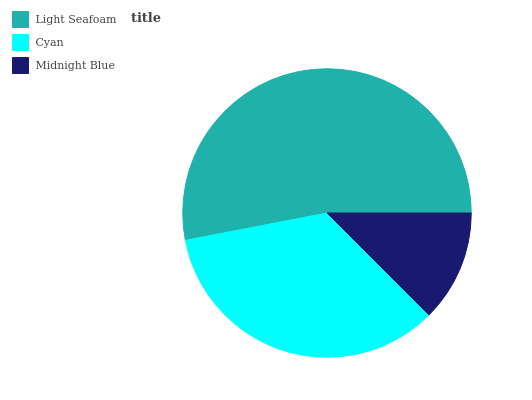Is Midnight Blue the minimum?
Answer yes or no. Yes. Is Light Seafoam the maximum?
Answer yes or no. Yes. Is Cyan the minimum?
Answer yes or no. No. Is Cyan the maximum?
Answer yes or no. No. Is Light Seafoam greater than Cyan?
Answer yes or no. Yes. Is Cyan less than Light Seafoam?
Answer yes or no. Yes. Is Cyan greater than Light Seafoam?
Answer yes or no. No. Is Light Seafoam less than Cyan?
Answer yes or no. No. Is Cyan the high median?
Answer yes or no. Yes. Is Cyan the low median?
Answer yes or no. Yes. Is Light Seafoam the high median?
Answer yes or no. No. Is Midnight Blue the low median?
Answer yes or no. No. 